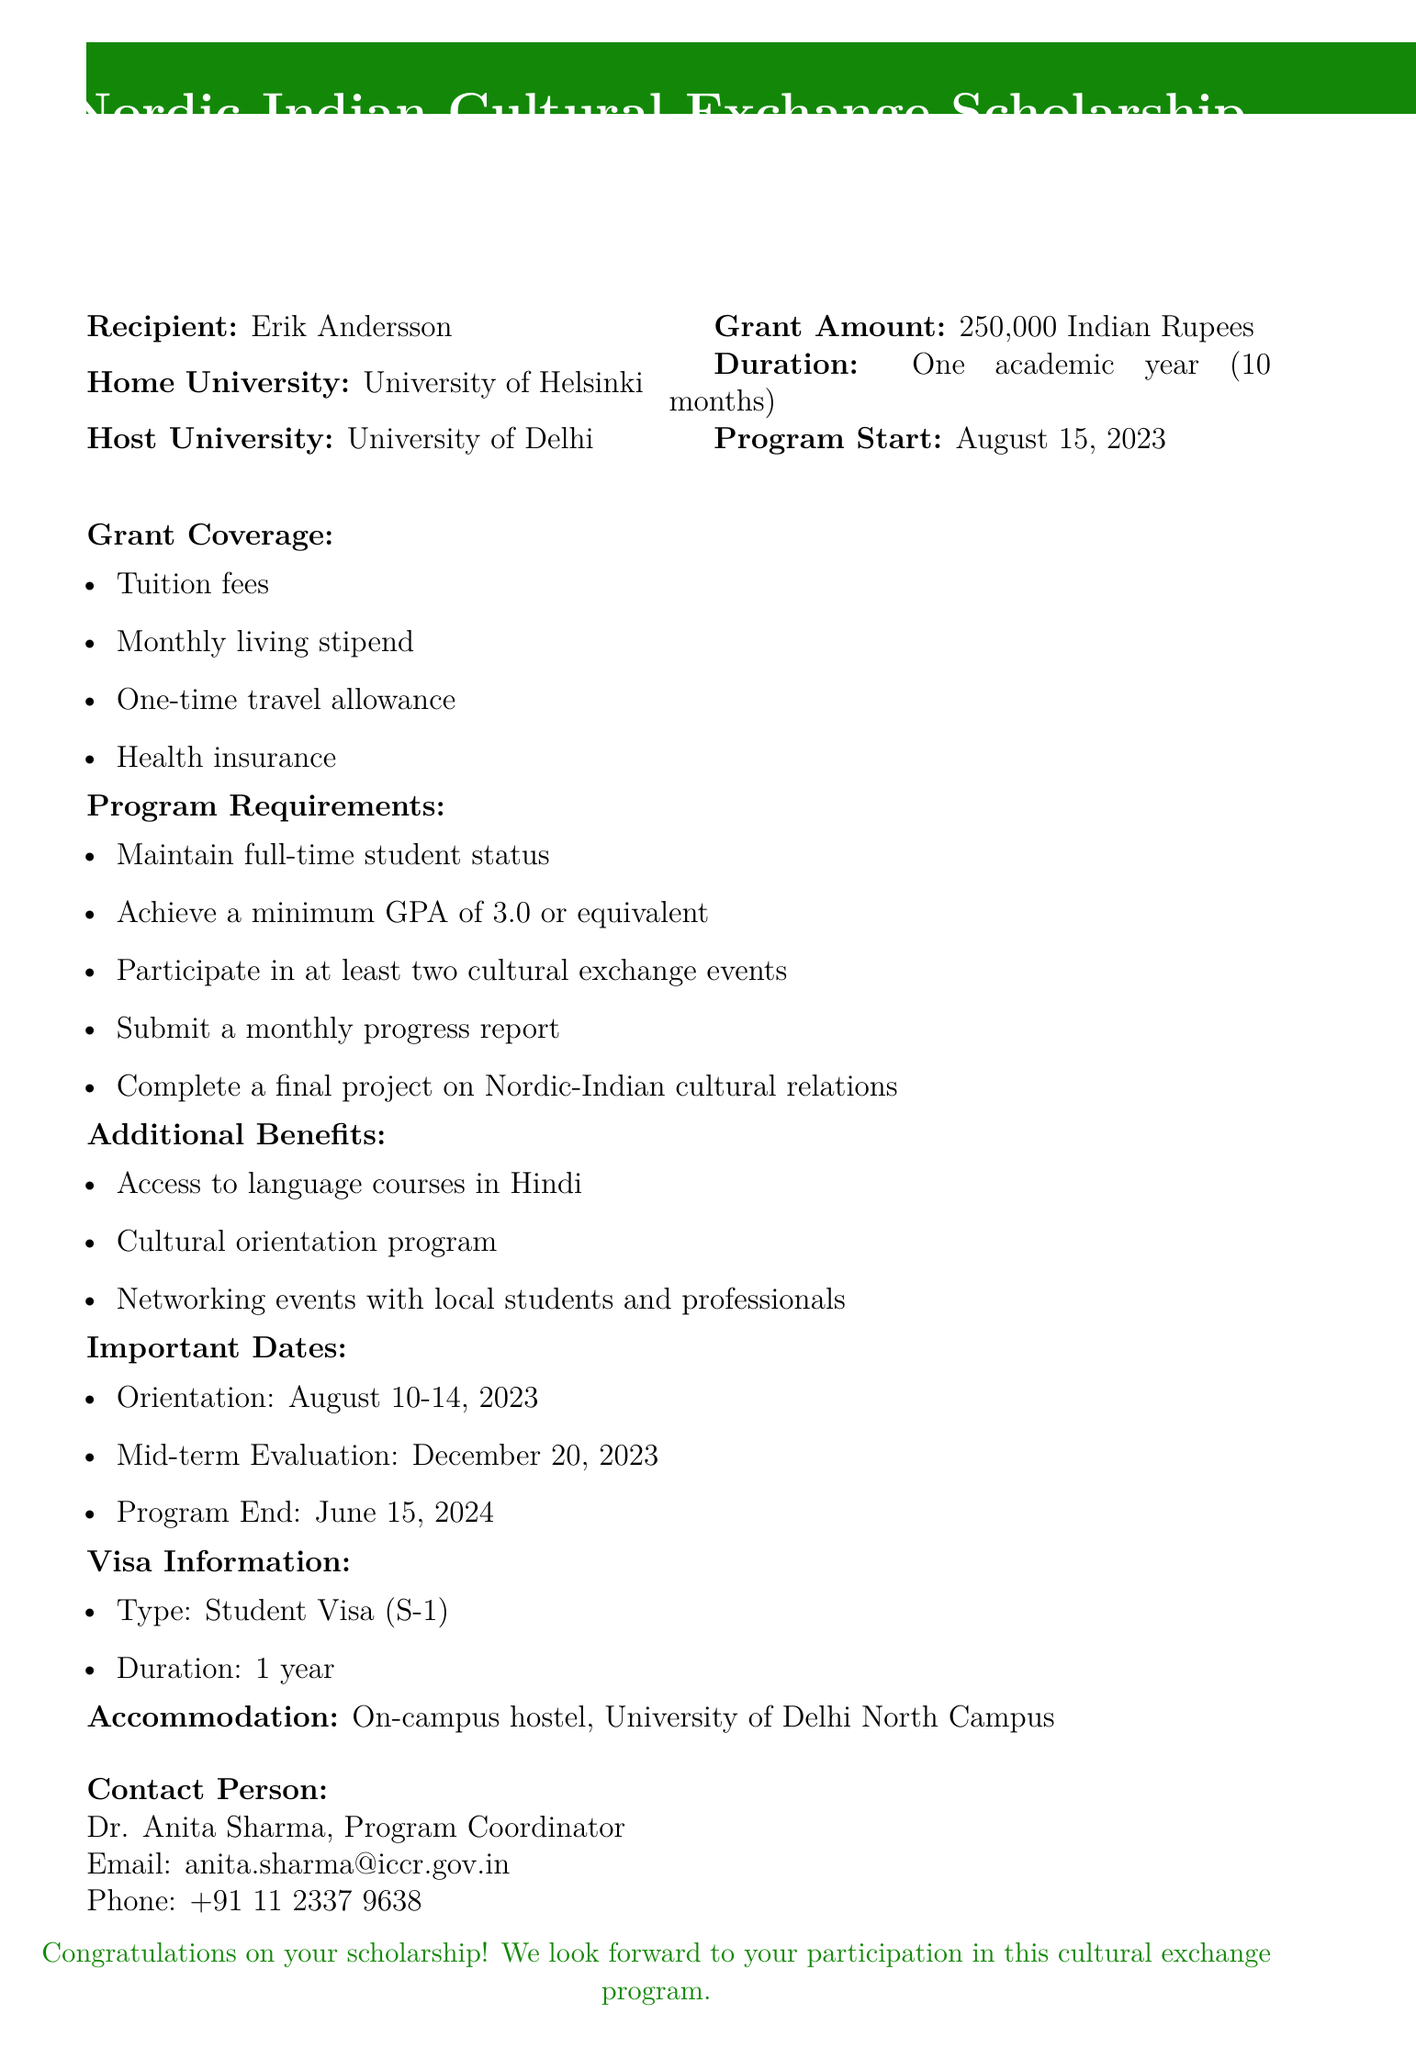What is the grant amount? The grant amount is explicitly mentioned in the document.
Answer: 250,000 Indian Rupees What is the duration of the scholarship? The duration refers to how long the scholarship covers, which is specified in the document.
Answer: One academic year (10 months) Who is the recipient of the scholarship? The document clearly identifies the recipient's name.
Answer: Erik Andersson What is the minimum GPA requirement? The GPA requirement is outlined in the program requirements section of the document.
Answer: 3.0 What is the host university? The host university is specified in the document as the institution where the recipient will study.
Answer: University of Delhi When does the program start? The start date of the program is provided in the important dates section.
Answer: August 15, 2023 What type of accommodation is provided? The accommodation type is described in the accommodation section of the document.
Answer: On-campus hostel Who should be contacted for more information? The document lists a contact person for inquiries regarding the scholarship.
Answer: Dr. Anita Sharma How many cultural exchange events must participants attend? The number of required cultural exchange events is stated in the program requirements.
Answer: At least two 